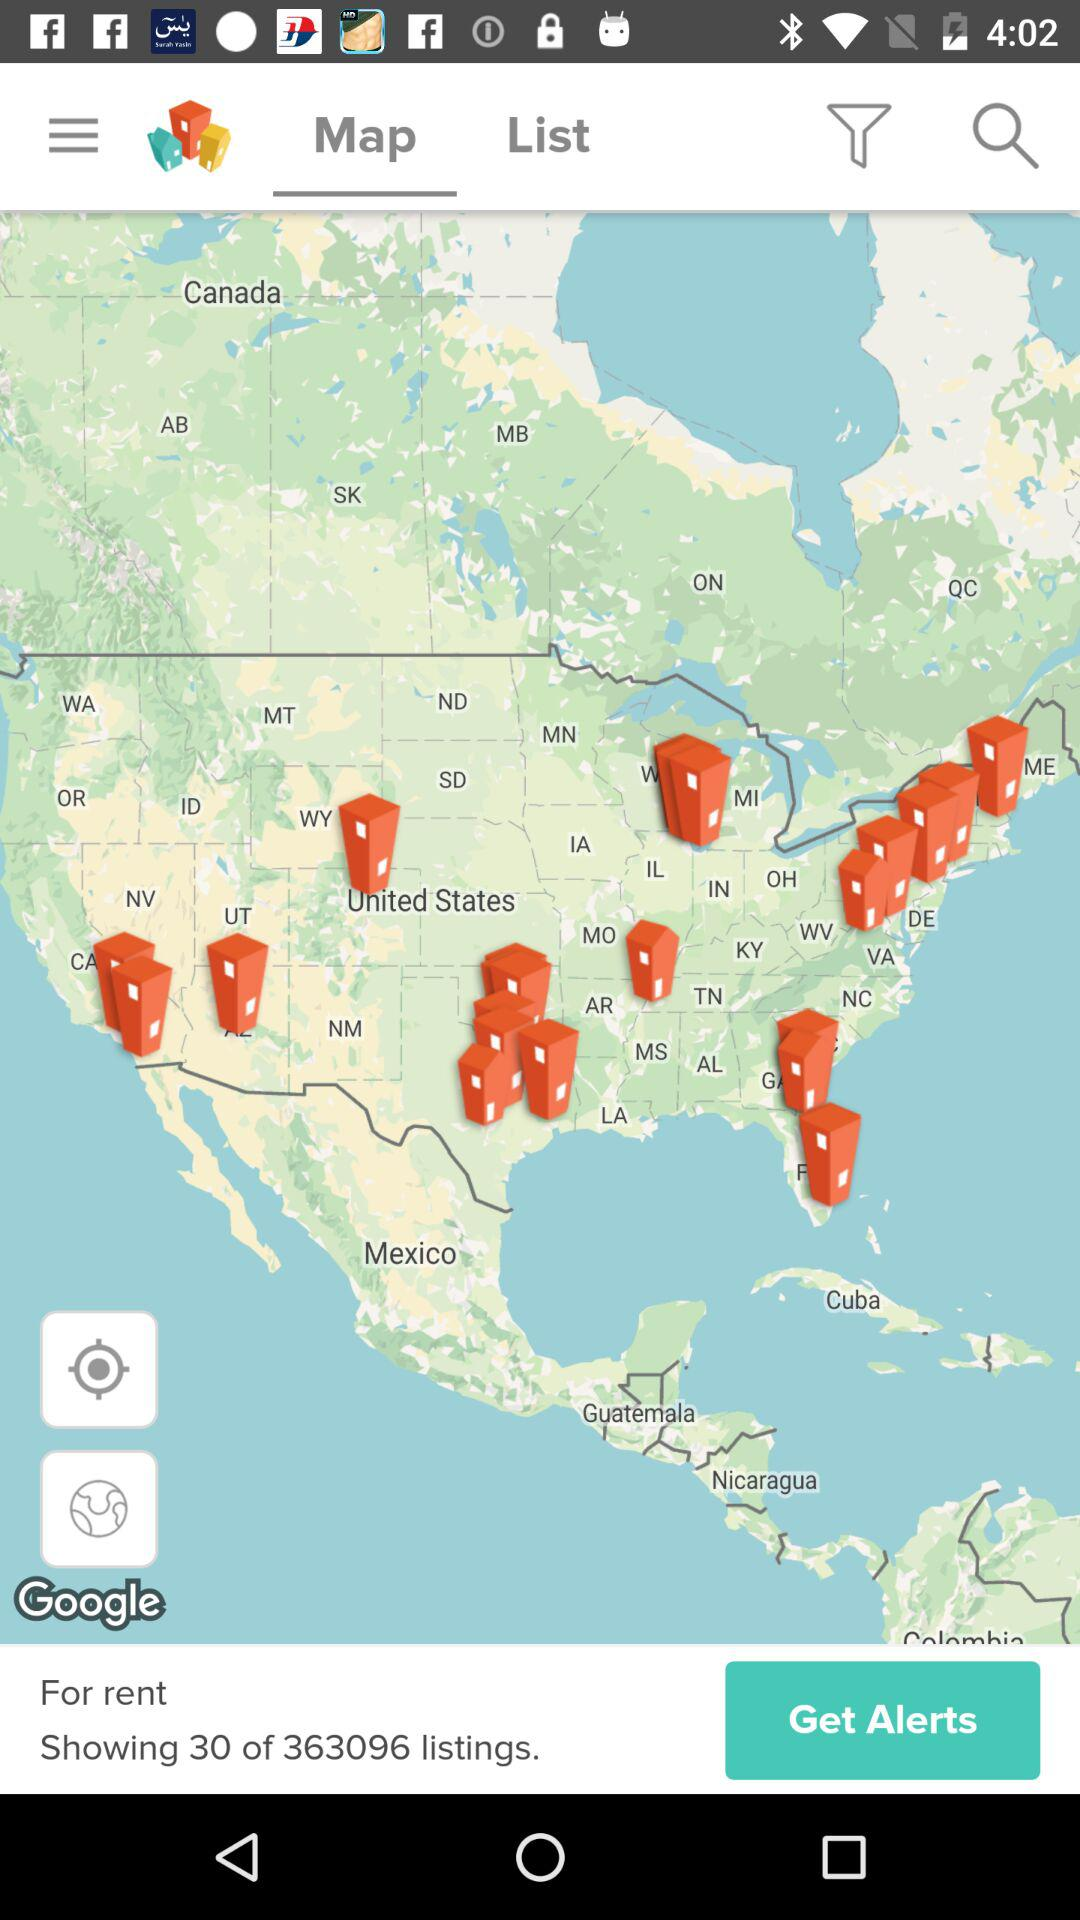Which tab am I on? You are on the "Map" tab. 